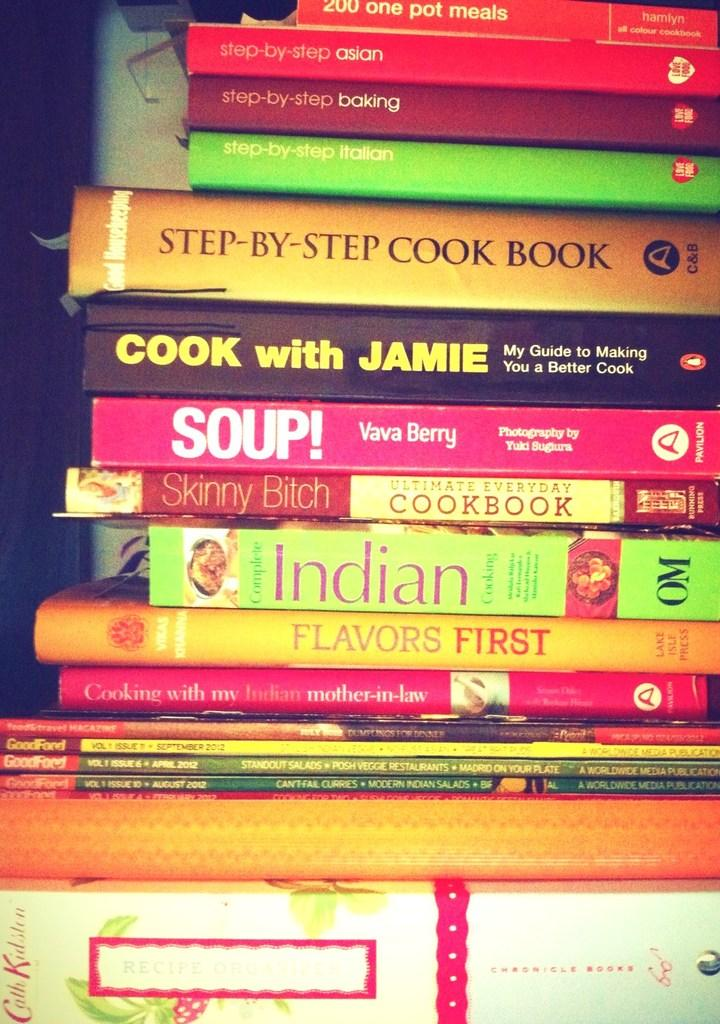<image>
Present a compact description of the photo's key features. A tall stack of cook books and books about food. 